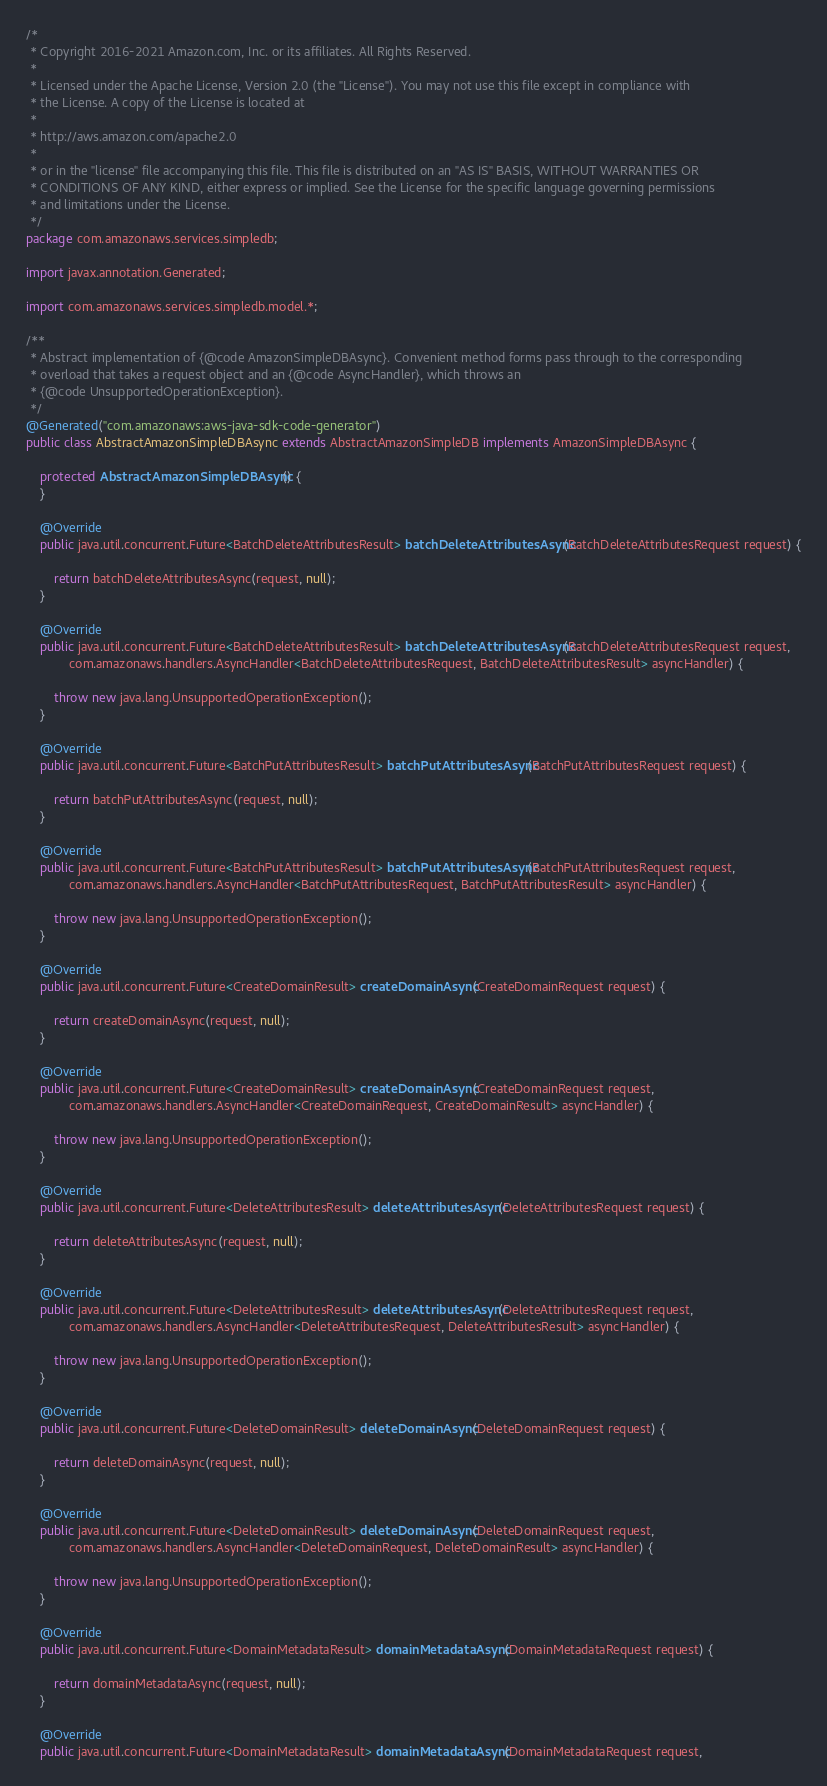<code> <loc_0><loc_0><loc_500><loc_500><_Java_>/*
 * Copyright 2016-2021 Amazon.com, Inc. or its affiliates. All Rights Reserved.
 * 
 * Licensed under the Apache License, Version 2.0 (the "License"). You may not use this file except in compliance with
 * the License. A copy of the License is located at
 * 
 * http://aws.amazon.com/apache2.0
 * 
 * or in the "license" file accompanying this file. This file is distributed on an "AS IS" BASIS, WITHOUT WARRANTIES OR
 * CONDITIONS OF ANY KIND, either express or implied. See the License for the specific language governing permissions
 * and limitations under the License.
 */
package com.amazonaws.services.simpledb;

import javax.annotation.Generated;

import com.amazonaws.services.simpledb.model.*;

/**
 * Abstract implementation of {@code AmazonSimpleDBAsync}. Convenient method forms pass through to the corresponding
 * overload that takes a request object and an {@code AsyncHandler}, which throws an
 * {@code UnsupportedOperationException}.
 */
@Generated("com.amazonaws:aws-java-sdk-code-generator")
public class AbstractAmazonSimpleDBAsync extends AbstractAmazonSimpleDB implements AmazonSimpleDBAsync {

    protected AbstractAmazonSimpleDBAsync() {
    }

    @Override
    public java.util.concurrent.Future<BatchDeleteAttributesResult> batchDeleteAttributesAsync(BatchDeleteAttributesRequest request) {

        return batchDeleteAttributesAsync(request, null);
    }

    @Override
    public java.util.concurrent.Future<BatchDeleteAttributesResult> batchDeleteAttributesAsync(BatchDeleteAttributesRequest request,
            com.amazonaws.handlers.AsyncHandler<BatchDeleteAttributesRequest, BatchDeleteAttributesResult> asyncHandler) {

        throw new java.lang.UnsupportedOperationException();
    }

    @Override
    public java.util.concurrent.Future<BatchPutAttributesResult> batchPutAttributesAsync(BatchPutAttributesRequest request) {

        return batchPutAttributesAsync(request, null);
    }

    @Override
    public java.util.concurrent.Future<BatchPutAttributesResult> batchPutAttributesAsync(BatchPutAttributesRequest request,
            com.amazonaws.handlers.AsyncHandler<BatchPutAttributesRequest, BatchPutAttributesResult> asyncHandler) {

        throw new java.lang.UnsupportedOperationException();
    }

    @Override
    public java.util.concurrent.Future<CreateDomainResult> createDomainAsync(CreateDomainRequest request) {

        return createDomainAsync(request, null);
    }

    @Override
    public java.util.concurrent.Future<CreateDomainResult> createDomainAsync(CreateDomainRequest request,
            com.amazonaws.handlers.AsyncHandler<CreateDomainRequest, CreateDomainResult> asyncHandler) {

        throw new java.lang.UnsupportedOperationException();
    }

    @Override
    public java.util.concurrent.Future<DeleteAttributesResult> deleteAttributesAsync(DeleteAttributesRequest request) {

        return deleteAttributesAsync(request, null);
    }

    @Override
    public java.util.concurrent.Future<DeleteAttributesResult> deleteAttributesAsync(DeleteAttributesRequest request,
            com.amazonaws.handlers.AsyncHandler<DeleteAttributesRequest, DeleteAttributesResult> asyncHandler) {

        throw new java.lang.UnsupportedOperationException();
    }

    @Override
    public java.util.concurrent.Future<DeleteDomainResult> deleteDomainAsync(DeleteDomainRequest request) {

        return deleteDomainAsync(request, null);
    }

    @Override
    public java.util.concurrent.Future<DeleteDomainResult> deleteDomainAsync(DeleteDomainRequest request,
            com.amazonaws.handlers.AsyncHandler<DeleteDomainRequest, DeleteDomainResult> asyncHandler) {

        throw new java.lang.UnsupportedOperationException();
    }

    @Override
    public java.util.concurrent.Future<DomainMetadataResult> domainMetadataAsync(DomainMetadataRequest request) {

        return domainMetadataAsync(request, null);
    }

    @Override
    public java.util.concurrent.Future<DomainMetadataResult> domainMetadataAsync(DomainMetadataRequest request,</code> 